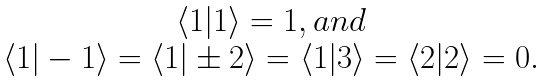<formula> <loc_0><loc_0><loc_500><loc_500>\begin{array} { c } \langle 1 | 1 \rangle = 1 , a n d \\ \langle 1 | - 1 \rangle = \langle 1 | \pm 2 \rangle = \langle 1 | 3 \rangle = \langle 2 | 2 \rangle = 0 . \end{array}</formula> 